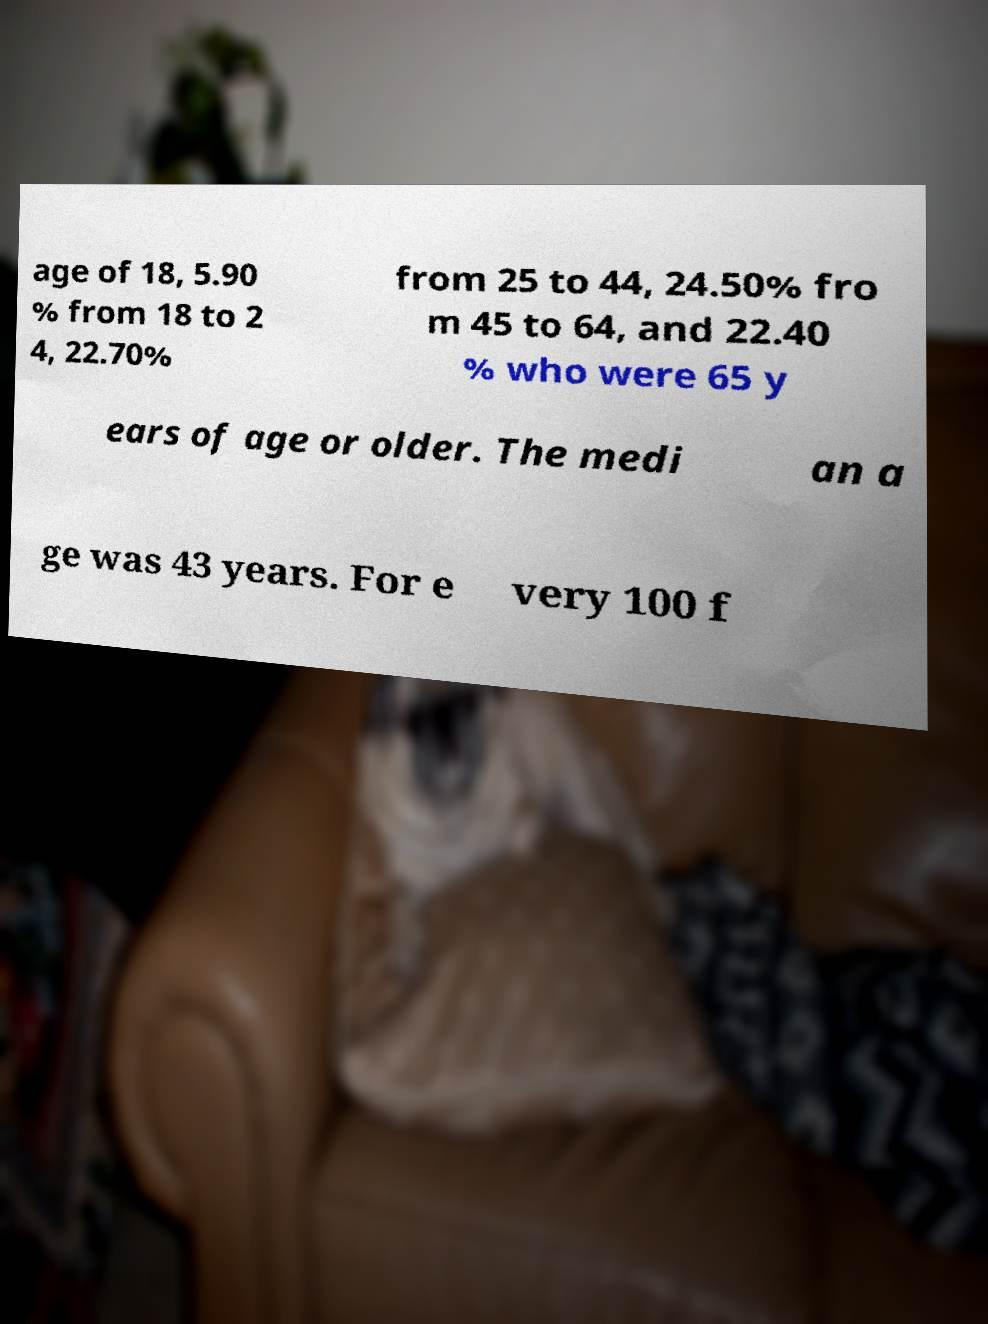Could you assist in decoding the text presented in this image and type it out clearly? age of 18, 5.90 % from 18 to 2 4, 22.70% from 25 to 44, 24.50% fro m 45 to 64, and 22.40 % who were 65 y ears of age or older. The medi an a ge was 43 years. For e very 100 f 